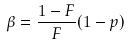<formula> <loc_0><loc_0><loc_500><loc_500>\beta = \frac { 1 - F } { F } ( 1 - p )</formula> 